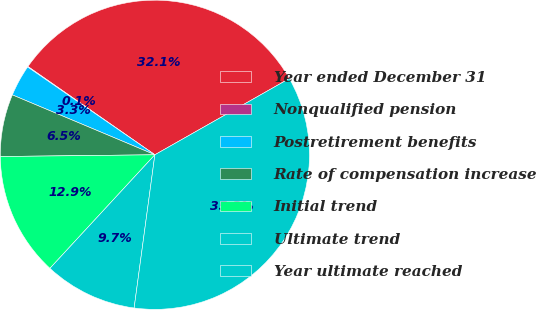<chart> <loc_0><loc_0><loc_500><loc_500><pie_chart><fcel>Year ended December 31<fcel>Nonqualified pension<fcel>Postretirement benefits<fcel>Rate of compensation increase<fcel>Initial trend<fcel>Ultimate trend<fcel>Year ultimate reached<nl><fcel>32.12%<fcel>0.06%<fcel>3.28%<fcel>6.51%<fcel>12.95%<fcel>9.73%<fcel>35.35%<nl></chart> 